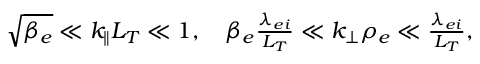Convert formula to latex. <formula><loc_0><loc_0><loc_500><loc_500>\begin{array} { r } { \sqrt { \beta _ { e } } \ll k _ { \| } L _ { T } \ll 1 , \quad \beta _ { e } \frac { \lambda _ { e i } } { L _ { T } } \ll k _ { \perp } \rho _ { e } \ll \frac { \lambda _ { e i } } { L _ { T } } , } \end{array}</formula> 